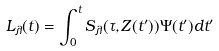<formula> <loc_0><loc_0><loc_500><loc_500>L _ { \lambda } ( t ) = \int ^ { t } _ { 0 } S _ { \lambda } ( \tau , Z ( t ^ { \prime } ) ) \Psi ( t ^ { \prime } ) d t ^ { \prime }</formula> 